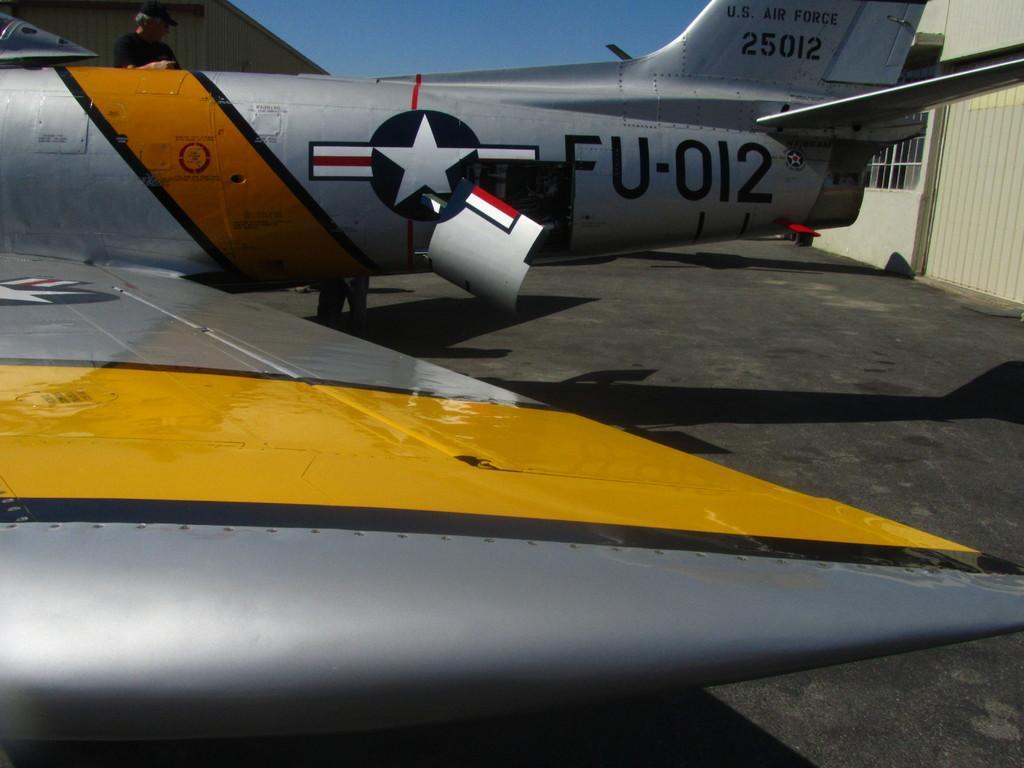Describe this image in one or two sentences. In this image In the foreground I can see vehicle part, at the top there is the sky, flight on which there is a text, symbol, person, on the right side I can see window, the wall. 